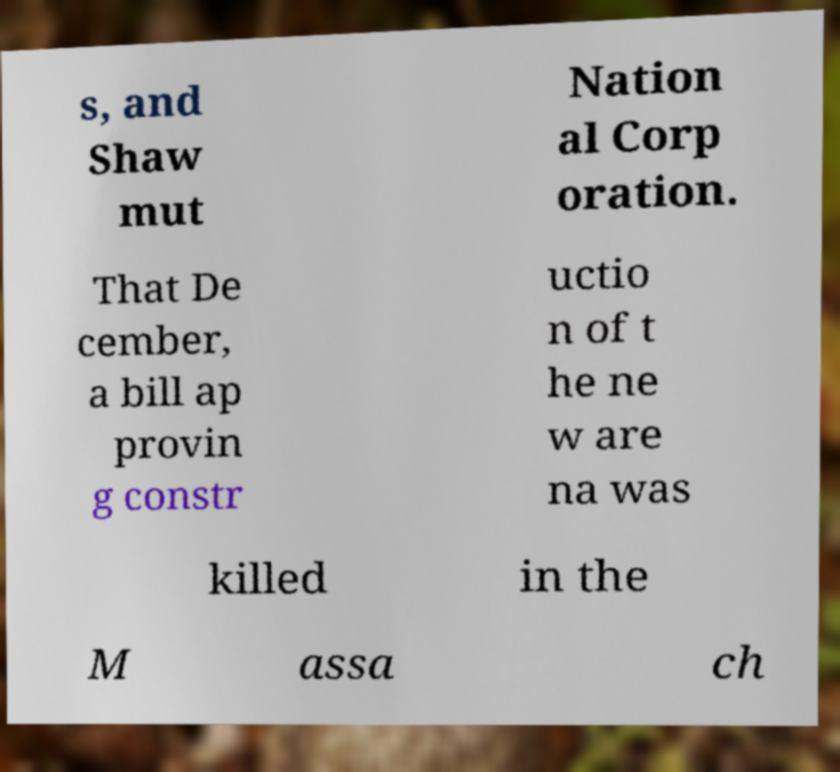Can you read and provide the text displayed in the image?This photo seems to have some interesting text. Can you extract and type it out for me? s, and Shaw mut Nation al Corp oration. That De cember, a bill ap provin g constr uctio n of t he ne w are na was killed in the M assa ch 